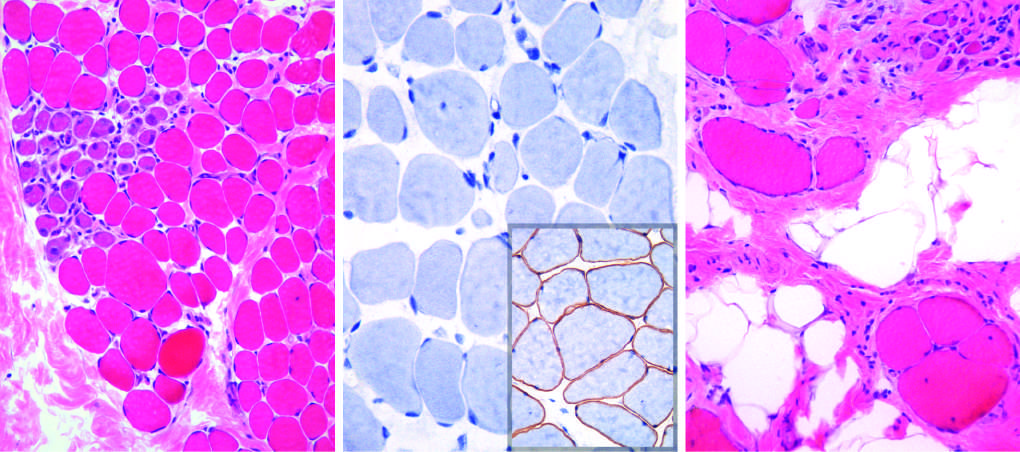what does immunohistochemical staining show?
Answer the question using a single word or phrase. A complete absence of membrane-associated dystrophin 